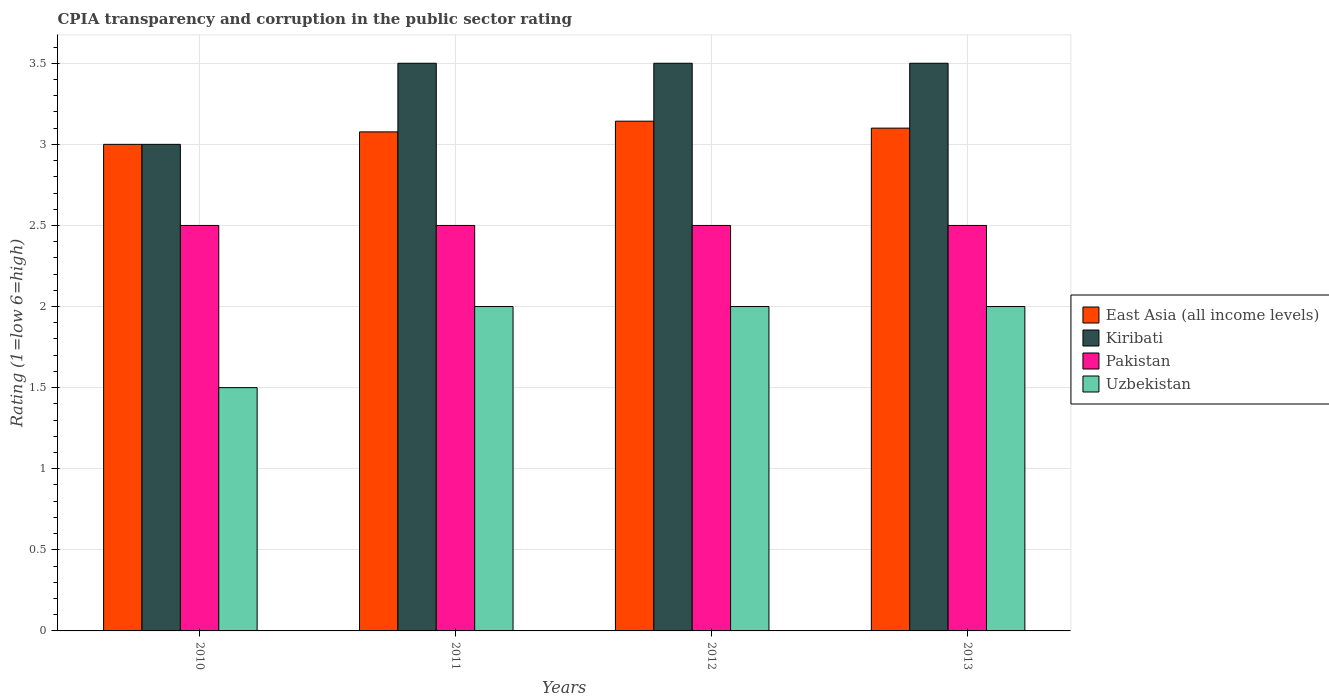How many groups of bars are there?
Provide a short and direct response. 4. How many bars are there on the 1st tick from the right?
Give a very brief answer. 4. Across all years, what is the maximum CPIA rating in Pakistan?
Provide a short and direct response. 2.5. In which year was the CPIA rating in East Asia (all income levels) maximum?
Offer a very short reply. 2012. What is the total CPIA rating in Pakistan in the graph?
Provide a short and direct response. 10. What is the difference between the CPIA rating in East Asia (all income levels) in 2010 and that in 2011?
Your response must be concise. -0.08. What is the difference between the CPIA rating in Uzbekistan in 2011 and the CPIA rating in East Asia (all income levels) in 2012?
Ensure brevity in your answer.  -1.14. What is the average CPIA rating in Uzbekistan per year?
Offer a very short reply. 1.88. In the year 2012, what is the difference between the CPIA rating in Pakistan and CPIA rating in Kiribati?
Ensure brevity in your answer.  -1. What is the ratio of the CPIA rating in Pakistan in 2012 to that in 2013?
Keep it short and to the point. 1. Is the CPIA rating in East Asia (all income levels) in 2010 less than that in 2013?
Keep it short and to the point. Yes. Is the difference between the CPIA rating in Pakistan in 2010 and 2013 greater than the difference between the CPIA rating in Kiribati in 2010 and 2013?
Make the answer very short. Yes. Is the sum of the CPIA rating in Pakistan in 2011 and 2012 greater than the maximum CPIA rating in Kiribati across all years?
Your answer should be compact. Yes. Is it the case that in every year, the sum of the CPIA rating in Uzbekistan and CPIA rating in Pakistan is greater than the sum of CPIA rating in Kiribati and CPIA rating in East Asia (all income levels)?
Provide a succinct answer. No. What does the 1st bar from the left in 2011 represents?
Offer a very short reply. East Asia (all income levels). What does the 1st bar from the right in 2010 represents?
Offer a very short reply. Uzbekistan. How many bars are there?
Keep it short and to the point. 16. Are all the bars in the graph horizontal?
Provide a succinct answer. No. Does the graph contain any zero values?
Make the answer very short. No. Does the graph contain grids?
Your answer should be compact. Yes. Where does the legend appear in the graph?
Offer a terse response. Center right. How many legend labels are there?
Ensure brevity in your answer.  4. What is the title of the graph?
Provide a short and direct response. CPIA transparency and corruption in the public sector rating. What is the label or title of the Y-axis?
Your response must be concise. Rating (1=low 6=high). What is the Rating (1=low 6=high) of Kiribati in 2010?
Your answer should be compact. 3. What is the Rating (1=low 6=high) of Pakistan in 2010?
Make the answer very short. 2.5. What is the Rating (1=low 6=high) in East Asia (all income levels) in 2011?
Keep it short and to the point. 3.08. What is the Rating (1=low 6=high) in East Asia (all income levels) in 2012?
Keep it short and to the point. 3.14. What is the Rating (1=low 6=high) in Pakistan in 2012?
Provide a short and direct response. 2.5. What is the Rating (1=low 6=high) of Uzbekistan in 2012?
Offer a terse response. 2. What is the Rating (1=low 6=high) of Pakistan in 2013?
Your response must be concise. 2.5. Across all years, what is the maximum Rating (1=low 6=high) of East Asia (all income levels)?
Make the answer very short. 3.14. Across all years, what is the maximum Rating (1=low 6=high) of Uzbekistan?
Provide a succinct answer. 2. Across all years, what is the minimum Rating (1=low 6=high) in Kiribati?
Provide a short and direct response. 3. Across all years, what is the minimum Rating (1=low 6=high) of Pakistan?
Offer a terse response. 2.5. Across all years, what is the minimum Rating (1=low 6=high) of Uzbekistan?
Provide a succinct answer. 1.5. What is the total Rating (1=low 6=high) in East Asia (all income levels) in the graph?
Make the answer very short. 12.32. What is the difference between the Rating (1=low 6=high) in East Asia (all income levels) in 2010 and that in 2011?
Your answer should be very brief. -0.08. What is the difference between the Rating (1=low 6=high) in Kiribati in 2010 and that in 2011?
Provide a short and direct response. -0.5. What is the difference between the Rating (1=low 6=high) in Pakistan in 2010 and that in 2011?
Provide a succinct answer. 0. What is the difference between the Rating (1=low 6=high) of East Asia (all income levels) in 2010 and that in 2012?
Your response must be concise. -0.14. What is the difference between the Rating (1=low 6=high) in East Asia (all income levels) in 2010 and that in 2013?
Your response must be concise. -0.1. What is the difference between the Rating (1=low 6=high) in Pakistan in 2010 and that in 2013?
Offer a very short reply. 0. What is the difference between the Rating (1=low 6=high) of East Asia (all income levels) in 2011 and that in 2012?
Your response must be concise. -0.07. What is the difference between the Rating (1=low 6=high) of Uzbekistan in 2011 and that in 2012?
Your answer should be compact. 0. What is the difference between the Rating (1=low 6=high) of East Asia (all income levels) in 2011 and that in 2013?
Provide a succinct answer. -0.02. What is the difference between the Rating (1=low 6=high) of Uzbekistan in 2011 and that in 2013?
Give a very brief answer. 0. What is the difference between the Rating (1=low 6=high) in East Asia (all income levels) in 2012 and that in 2013?
Your answer should be compact. 0.04. What is the difference between the Rating (1=low 6=high) of Pakistan in 2012 and that in 2013?
Keep it short and to the point. 0. What is the difference between the Rating (1=low 6=high) of Uzbekistan in 2012 and that in 2013?
Offer a very short reply. 0. What is the difference between the Rating (1=low 6=high) in East Asia (all income levels) in 2010 and the Rating (1=low 6=high) in Uzbekistan in 2011?
Make the answer very short. 1. What is the difference between the Rating (1=low 6=high) in Kiribati in 2010 and the Rating (1=low 6=high) in Pakistan in 2011?
Your response must be concise. 0.5. What is the difference between the Rating (1=low 6=high) in Kiribati in 2010 and the Rating (1=low 6=high) in Uzbekistan in 2011?
Your response must be concise. 1. What is the difference between the Rating (1=low 6=high) in East Asia (all income levels) in 2010 and the Rating (1=low 6=high) in Uzbekistan in 2012?
Offer a very short reply. 1. What is the difference between the Rating (1=low 6=high) in Kiribati in 2010 and the Rating (1=low 6=high) in Pakistan in 2012?
Your answer should be compact. 0.5. What is the difference between the Rating (1=low 6=high) in Pakistan in 2010 and the Rating (1=low 6=high) in Uzbekistan in 2012?
Provide a succinct answer. 0.5. What is the difference between the Rating (1=low 6=high) in East Asia (all income levels) in 2010 and the Rating (1=low 6=high) in Kiribati in 2013?
Your response must be concise. -0.5. What is the difference between the Rating (1=low 6=high) of East Asia (all income levels) in 2010 and the Rating (1=low 6=high) of Pakistan in 2013?
Offer a terse response. 0.5. What is the difference between the Rating (1=low 6=high) in East Asia (all income levels) in 2010 and the Rating (1=low 6=high) in Uzbekistan in 2013?
Ensure brevity in your answer.  1. What is the difference between the Rating (1=low 6=high) of Kiribati in 2010 and the Rating (1=low 6=high) of Uzbekistan in 2013?
Make the answer very short. 1. What is the difference between the Rating (1=low 6=high) of Pakistan in 2010 and the Rating (1=low 6=high) of Uzbekistan in 2013?
Provide a succinct answer. 0.5. What is the difference between the Rating (1=low 6=high) in East Asia (all income levels) in 2011 and the Rating (1=low 6=high) in Kiribati in 2012?
Keep it short and to the point. -0.42. What is the difference between the Rating (1=low 6=high) of East Asia (all income levels) in 2011 and the Rating (1=low 6=high) of Pakistan in 2012?
Your answer should be very brief. 0.58. What is the difference between the Rating (1=low 6=high) of East Asia (all income levels) in 2011 and the Rating (1=low 6=high) of Kiribati in 2013?
Provide a short and direct response. -0.42. What is the difference between the Rating (1=low 6=high) of East Asia (all income levels) in 2011 and the Rating (1=low 6=high) of Pakistan in 2013?
Make the answer very short. 0.58. What is the difference between the Rating (1=low 6=high) in Kiribati in 2011 and the Rating (1=low 6=high) in Pakistan in 2013?
Offer a very short reply. 1. What is the difference between the Rating (1=low 6=high) in Kiribati in 2011 and the Rating (1=low 6=high) in Uzbekistan in 2013?
Your answer should be compact. 1.5. What is the difference between the Rating (1=low 6=high) of Pakistan in 2011 and the Rating (1=low 6=high) of Uzbekistan in 2013?
Your answer should be compact. 0.5. What is the difference between the Rating (1=low 6=high) of East Asia (all income levels) in 2012 and the Rating (1=low 6=high) of Kiribati in 2013?
Offer a terse response. -0.36. What is the difference between the Rating (1=low 6=high) in East Asia (all income levels) in 2012 and the Rating (1=low 6=high) in Pakistan in 2013?
Give a very brief answer. 0.64. What is the difference between the Rating (1=low 6=high) in East Asia (all income levels) in 2012 and the Rating (1=low 6=high) in Uzbekistan in 2013?
Provide a succinct answer. 1.14. What is the difference between the Rating (1=low 6=high) in Kiribati in 2012 and the Rating (1=low 6=high) in Pakistan in 2013?
Provide a succinct answer. 1. What is the average Rating (1=low 6=high) of East Asia (all income levels) per year?
Your response must be concise. 3.08. What is the average Rating (1=low 6=high) of Kiribati per year?
Your answer should be very brief. 3.38. What is the average Rating (1=low 6=high) in Uzbekistan per year?
Give a very brief answer. 1.88. In the year 2010, what is the difference between the Rating (1=low 6=high) of East Asia (all income levels) and Rating (1=low 6=high) of Uzbekistan?
Your response must be concise. 1.5. In the year 2011, what is the difference between the Rating (1=low 6=high) of East Asia (all income levels) and Rating (1=low 6=high) of Kiribati?
Offer a terse response. -0.42. In the year 2011, what is the difference between the Rating (1=low 6=high) in East Asia (all income levels) and Rating (1=low 6=high) in Pakistan?
Provide a short and direct response. 0.58. In the year 2011, what is the difference between the Rating (1=low 6=high) of East Asia (all income levels) and Rating (1=low 6=high) of Uzbekistan?
Keep it short and to the point. 1.08. In the year 2011, what is the difference between the Rating (1=low 6=high) of Kiribati and Rating (1=low 6=high) of Pakistan?
Your answer should be very brief. 1. In the year 2011, what is the difference between the Rating (1=low 6=high) in Kiribati and Rating (1=low 6=high) in Uzbekistan?
Provide a succinct answer. 1.5. In the year 2012, what is the difference between the Rating (1=low 6=high) of East Asia (all income levels) and Rating (1=low 6=high) of Kiribati?
Make the answer very short. -0.36. In the year 2012, what is the difference between the Rating (1=low 6=high) of East Asia (all income levels) and Rating (1=low 6=high) of Pakistan?
Your response must be concise. 0.64. In the year 2012, what is the difference between the Rating (1=low 6=high) of East Asia (all income levels) and Rating (1=low 6=high) of Uzbekistan?
Keep it short and to the point. 1.14. In the year 2012, what is the difference between the Rating (1=low 6=high) in Kiribati and Rating (1=low 6=high) in Uzbekistan?
Make the answer very short. 1.5. In the year 2012, what is the difference between the Rating (1=low 6=high) of Pakistan and Rating (1=low 6=high) of Uzbekistan?
Your response must be concise. 0.5. In the year 2013, what is the difference between the Rating (1=low 6=high) in East Asia (all income levels) and Rating (1=low 6=high) in Pakistan?
Ensure brevity in your answer.  0.6. What is the ratio of the Rating (1=low 6=high) of East Asia (all income levels) in 2010 to that in 2011?
Make the answer very short. 0.97. What is the ratio of the Rating (1=low 6=high) of Pakistan in 2010 to that in 2011?
Provide a succinct answer. 1. What is the ratio of the Rating (1=low 6=high) of Uzbekistan in 2010 to that in 2011?
Provide a succinct answer. 0.75. What is the ratio of the Rating (1=low 6=high) of East Asia (all income levels) in 2010 to that in 2012?
Provide a succinct answer. 0.95. What is the ratio of the Rating (1=low 6=high) in Kiribati in 2010 to that in 2012?
Provide a short and direct response. 0.86. What is the ratio of the Rating (1=low 6=high) in Pakistan in 2010 to that in 2012?
Your answer should be compact. 1. What is the ratio of the Rating (1=low 6=high) of East Asia (all income levels) in 2010 to that in 2013?
Provide a short and direct response. 0.97. What is the ratio of the Rating (1=low 6=high) in Kiribati in 2011 to that in 2012?
Provide a succinct answer. 1. What is the ratio of the Rating (1=low 6=high) of East Asia (all income levels) in 2011 to that in 2013?
Offer a very short reply. 0.99. What is the ratio of the Rating (1=low 6=high) in Pakistan in 2011 to that in 2013?
Give a very brief answer. 1. What is the ratio of the Rating (1=low 6=high) in East Asia (all income levels) in 2012 to that in 2013?
Make the answer very short. 1.01. What is the ratio of the Rating (1=low 6=high) of Kiribati in 2012 to that in 2013?
Your answer should be very brief. 1. What is the ratio of the Rating (1=low 6=high) in Uzbekistan in 2012 to that in 2013?
Provide a succinct answer. 1. What is the difference between the highest and the second highest Rating (1=low 6=high) of East Asia (all income levels)?
Offer a very short reply. 0.04. What is the difference between the highest and the second highest Rating (1=low 6=high) in Uzbekistan?
Give a very brief answer. 0. What is the difference between the highest and the lowest Rating (1=low 6=high) in East Asia (all income levels)?
Your answer should be compact. 0.14. What is the difference between the highest and the lowest Rating (1=low 6=high) in Pakistan?
Offer a terse response. 0. What is the difference between the highest and the lowest Rating (1=low 6=high) in Uzbekistan?
Keep it short and to the point. 0.5. 